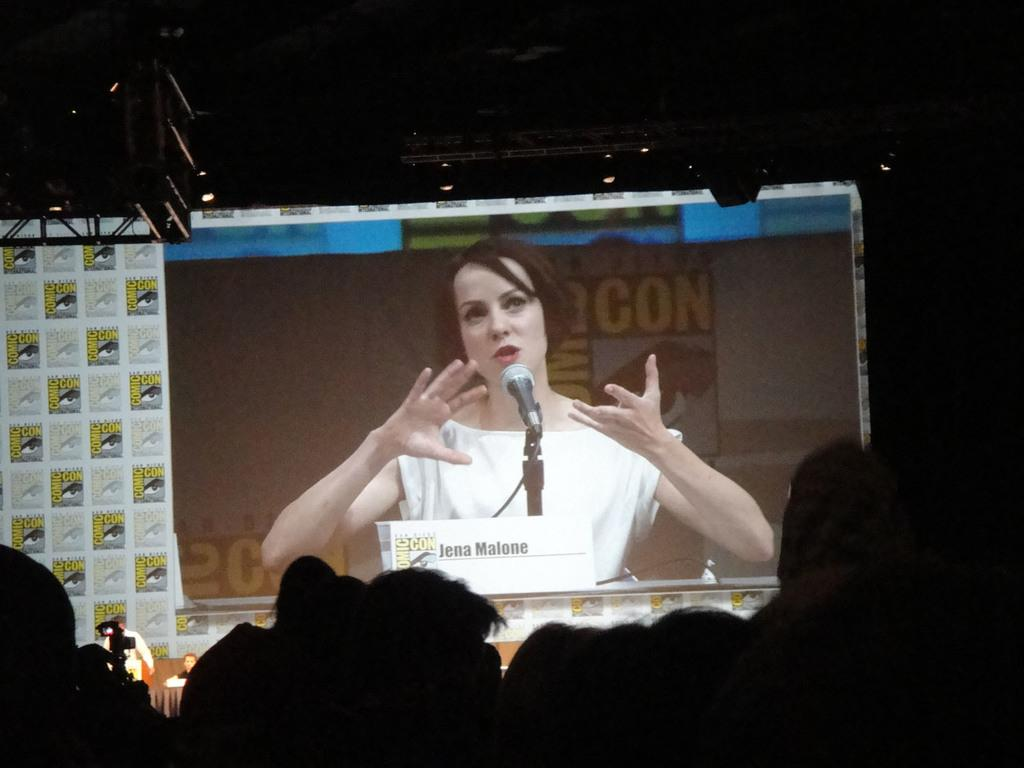Who is the main subject in the image? There is a girl in the center of the image. Where are the other persons located in the image? The persons are at the bottom of the image. What can be seen in the background of the image? There are lights in the background of the image. What type of van is parked next to the girl in the image? There is no van present in the image; it only features a girl, other persons, and lights in the background. 